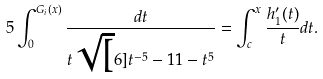Convert formula to latex. <formula><loc_0><loc_0><loc_500><loc_500>5 \int ^ { G _ { i } ( x ) } _ { 0 } \frac { d t } { t \sqrt { [ } 6 ] { t ^ { - 5 } - 1 1 - t ^ { 5 } } } = \int ^ { x } _ { c } \frac { h ^ { \prime } _ { 1 } ( t ) } { t } d t .</formula> 